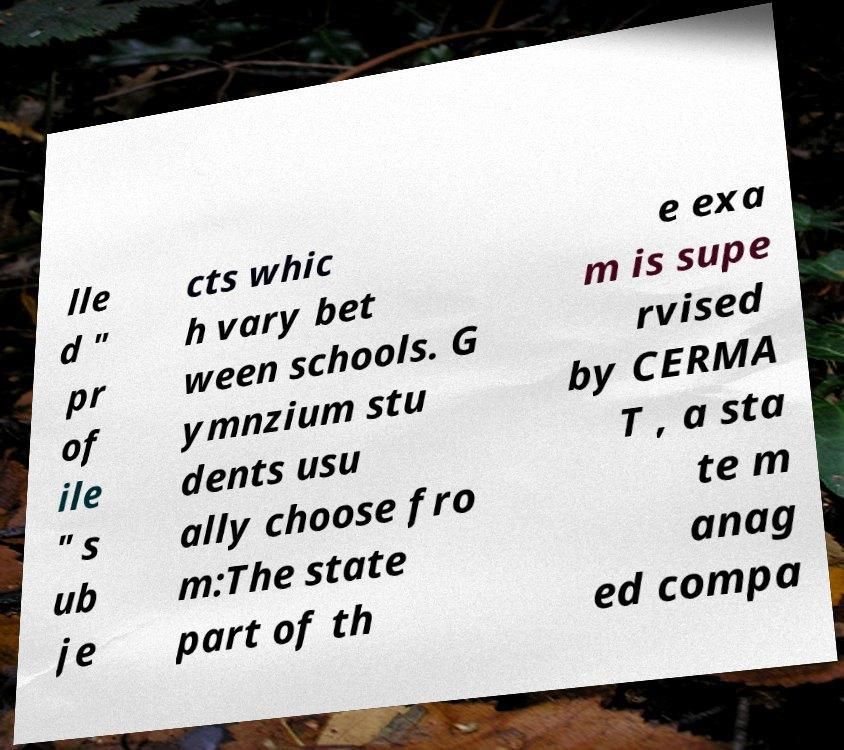There's text embedded in this image that I need extracted. Can you transcribe it verbatim? lle d " pr of ile " s ub je cts whic h vary bet ween schools. G ymnzium stu dents usu ally choose fro m:The state part of th e exa m is supe rvised by CERMA T , a sta te m anag ed compa 